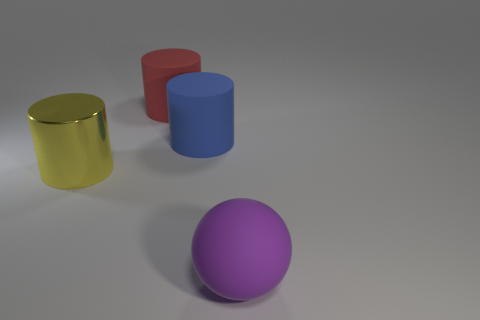Is there anything else that is the same material as the yellow cylinder?
Your answer should be very brief. No. What number of other things are made of the same material as the big red object?
Offer a terse response. 2. There is a yellow cylinder that is the same size as the blue rubber cylinder; what material is it?
Make the answer very short. Metal. Does the matte thing behind the blue cylinder have the same shape as the large matte thing in front of the big yellow object?
Your answer should be compact. No. The purple rubber thing that is the same size as the blue rubber thing is what shape?
Keep it short and to the point. Sphere. Is the cylinder that is to the right of the large red matte thing made of the same material as the object behind the big blue cylinder?
Offer a very short reply. Yes. There is a matte thing that is in front of the yellow metal cylinder; is there a big yellow cylinder that is to the left of it?
Your response must be concise. Yes. The cylinder that is the same material as the blue object is what color?
Ensure brevity in your answer.  Red. Is the number of small yellow spheres greater than the number of big blue things?
Your response must be concise. No. What number of things are cylinders that are to the right of the yellow metal object or large blue matte things?
Offer a terse response. 2. 